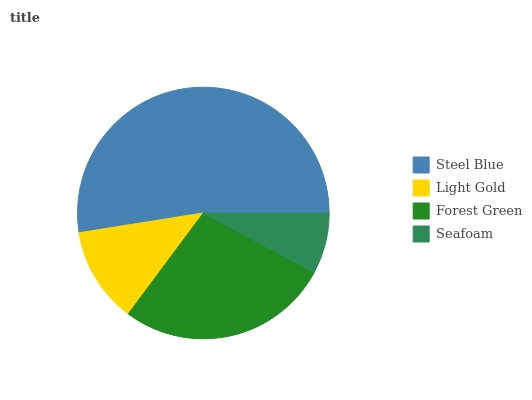Is Seafoam the minimum?
Answer yes or no. Yes. Is Steel Blue the maximum?
Answer yes or no. Yes. Is Light Gold the minimum?
Answer yes or no. No. Is Light Gold the maximum?
Answer yes or no. No. Is Steel Blue greater than Light Gold?
Answer yes or no. Yes. Is Light Gold less than Steel Blue?
Answer yes or no. Yes. Is Light Gold greater than Steel Blue?
Answer yes or no. No. Is Steel Blue less than Light Gold?
Answer yes or no. No. Is Forest Green the high median?
Answer yes or no. Yes. Is Light Gold the low median?
Answer yes or no. Yes. Is Light Gold the high median?
Answer yes or no. No. Is Seafoam the low median?
Answer yes or no. No. 